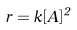<formula> <loc_0><loc_0><loc_500><loc_500>r = k [ A ] ^ { 2 }</formula> 